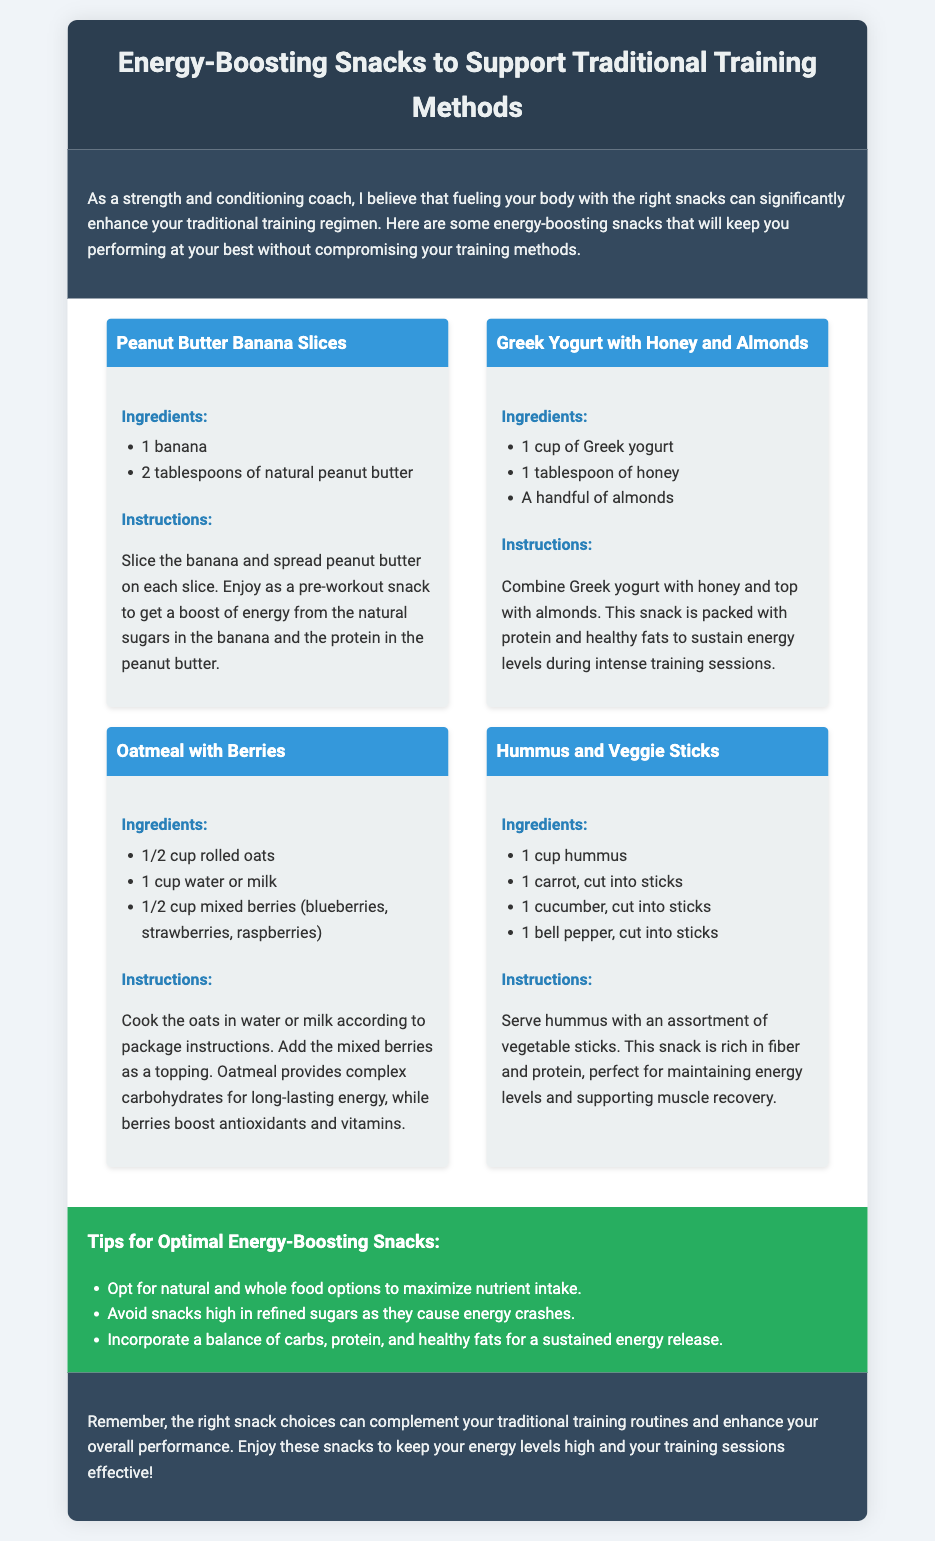What is the title of the document? The title of the document is stated in the header and describes the content, which focuses on snacks to support training methods.
Answer: Energy-Boosting Snacks to Support Traditional Training Methods How many snacks are mentioned in the document? The document lists four different snack recipes for energy-boosting options suitable for training.
Answer: 4 What ingredients are listed for the Peanut Butter Banana Slices? The ingredients for this snack are specifically mentioned in the snacks section, highlighting what's needed to prepare it.
Answer: 1 banana, 2 tablespoons of natural peanut butter What is the primary benefit of the Greek Yogurt with Honey and Almonds snack? The document explains that this snack is rich in protein and healthy fats, which are beneficial for training.
Answer: Sustain energy levels What should you avoid in snacks according to the Tips section? The Tips section advises on what types of snacks may not be optimal for energy, giving direction on how to select better choices.
Answer: Snacks high in refined sugars What is the serving suggestion for Hummus and Veggie Sticks? The instructions for this snack suggest how to appropriately serve it for consumption after preparation.
Answer: With an assortment of vegetable sticks How are oats cooked for the Oatmeal with Berries recipe? The instructions detail how to prepare the oats before adding toppings, informing about the cooking process.
Answer: In water or milk What is emphasized as an important aspect of energy-boosting snacks? The introduction stresses the importance of proper fueling alongside traditional training methods, laying out a clear focus.
Answer: Fueling your body What is a key component in the Oatmeal with Berries for providing energy? The document states that complex carbohydrates from oats are essential for energy, showing the nutritional benefit of this meal.
Answer: Complex carbohydrates 